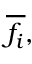<formula> <loc_0><loc_0><loc_500><loc_500>{ \overline { { f _ { i } } } } ,</formula> 